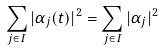<formula> <loc_0><loc_0><loc_500><loc_500>\sum _ { j \in I } | \alpha _ { j } ( t ) | ^ { 2 } = \sum _ { j \in I } | \alpha _ { j } | ^ { 2 }</formula> 